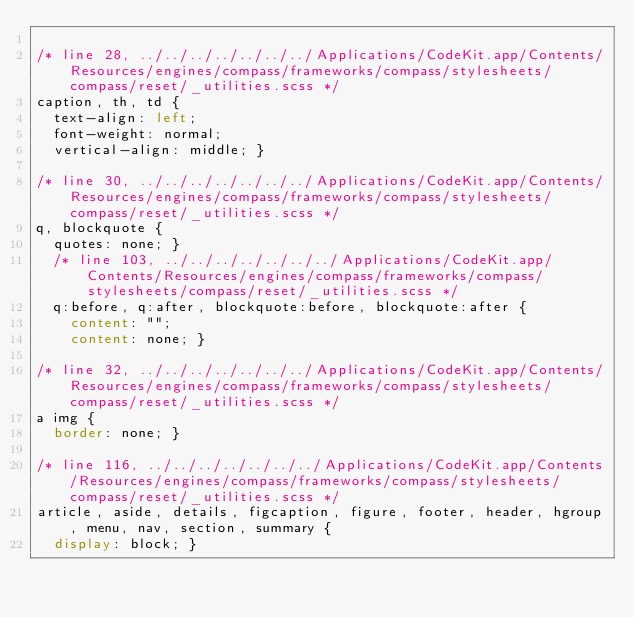<code> <loc_0><loc_0><loc_500><loc_500><_CSS_>
/* line 28, ../../../../../../../Applications/CodeKit.app/Contents/Resources/engines/compass/frameworks/compass/stylesheets/compass/reset/_utilities.scss */
caption, th, td {
  text-align: left;
  font-weight: normal;
  vertical-align: middle; }

/* line 30, ../../../../../../../Applications/CodeKit.app/Contents/Resources/engines/compass/frameworks/compass/stylesheets/compass/reset/_utilities.scss */
q, blockquote {
  quotes: none; }
  /* line 103, ../../../../../../../Applications/CodeKit.app/Contents/Resources/engines/compass/frameworks/compass/stylesheets/compass/reset/_utilities.scss */
  q:before, q:after, blockquote:before, blockquote:after {
    content: "";
    content: none; }

/* line 32, ../../../../../../../Applications/CodeKit.app/Contents/Resources/engines/compass/frameworks/compass/stylesheets/compass/reset/_utilities.scss */
a img {
  border: none; }

/* line 116, ../../../../../../../Applications/CodeKit.app/Contents/Resources/engines/compass/frameworks/compass/stylesheets/compass/reset/_utilities.scss */
article, aside, details, figcaption, figure, footer, header, hgroup, menu, nav, section, summary {
  display: block; }
</code> 